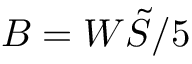Convert formula to latex. <formula><loc_0><loc_0><loc_500><loc_500>B = W \tilde { S } / 5</formula> 